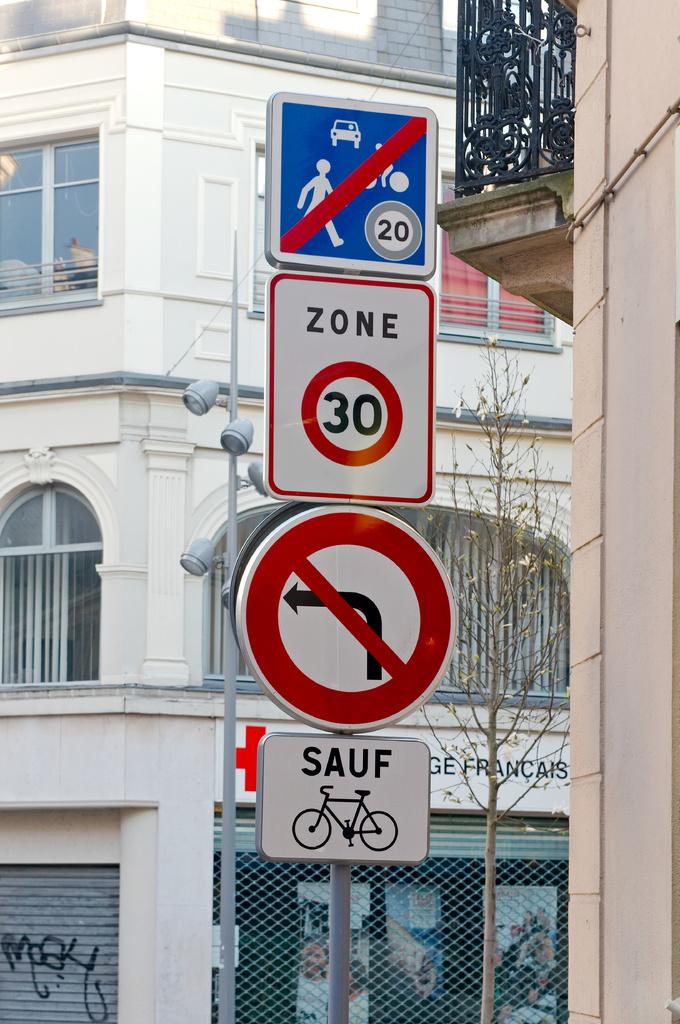What zone is on the sign?
Offer a terse response. 30. 